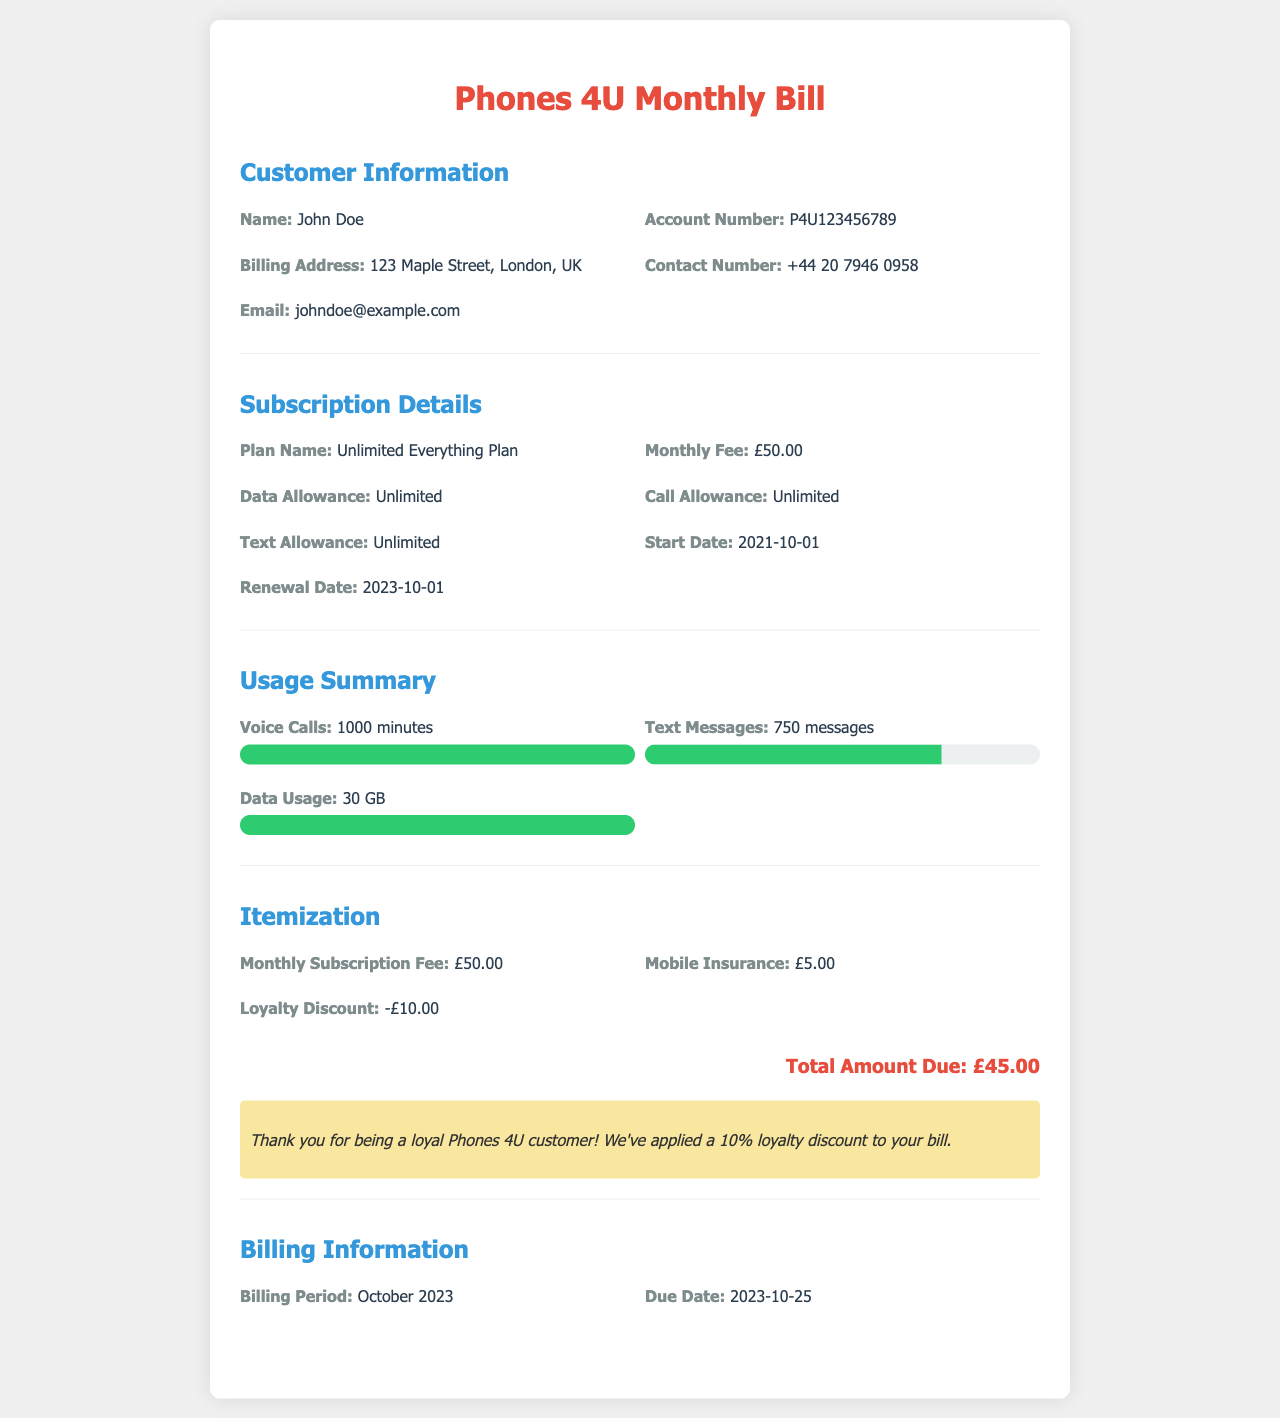what is the customer's name? The customer's name is stated in the "Customer Information" section of the document.
Answer: John Doe what is the account number? The account number can be found in the "Customer Information" section.
Answer: P4U123456789 what is the monthly subscription fee? The monthly subscription fee is listed under "Itemization" in the document.
Answer: £50.00 how much is the loyalty discount? The loyalty discount is mentioned in the "Itemization" section of the bill.
Answer: -£10.00 what is the total amount due? The total amount due is calculated from the "Itemization" section, taking into account the subscription fee, insurance, and discounts.
Answer: £45.00 when is the due date for the bill? The due date is specified in the "Billing Information" section of the document.
Answer: 2023-10-25 what type of plan does the customer have? The plan name is provided in the "Subscription Details" section.
Answer: Unlimited Everything Plan how many text messages were sent? The number of text messages is detailed in the "Usage Summary" section.
Answer: 750 messages what is the data usage for October 2023? The data usage is specified in the "Usage Summary" of the document.
Answer: 30 GB 